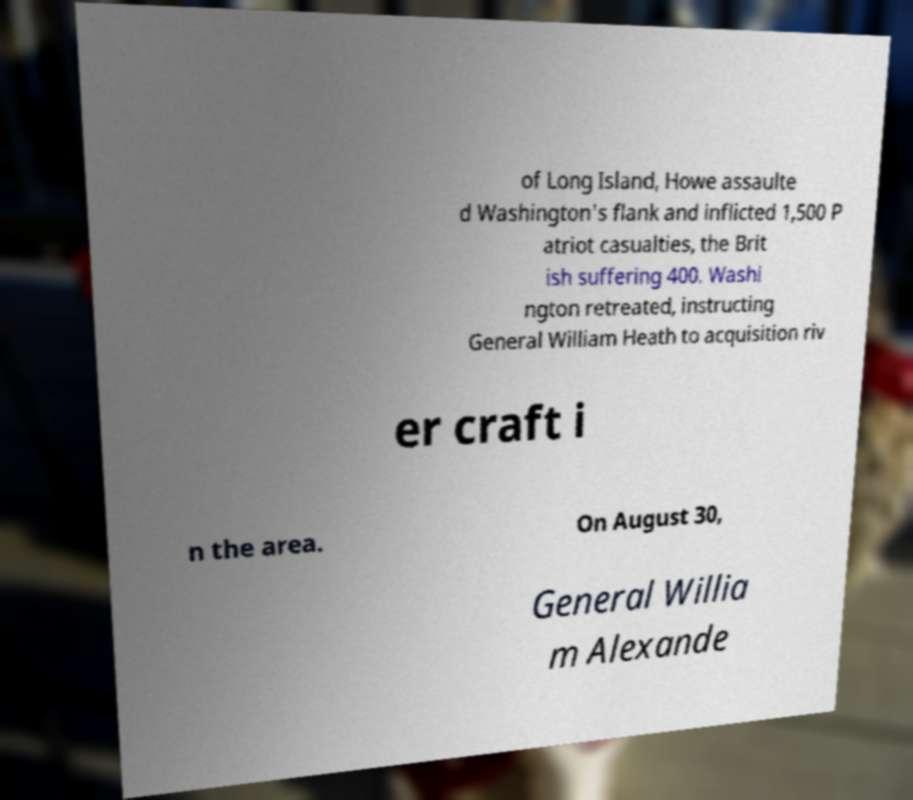There's text embedded in this image that I need extracted. Can you transcribe it verbatim? of Long Island, Howe assaulte d Washington's flank and inflicted 1,500 P atriot casualties, the Brit ish suffering 400. Washi ngton retreated, instructing General William Heath to acquisition riv er craft i n the area. On August 30, General Willia m Alexande 